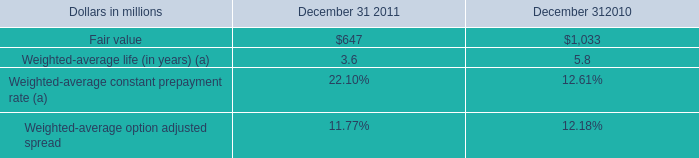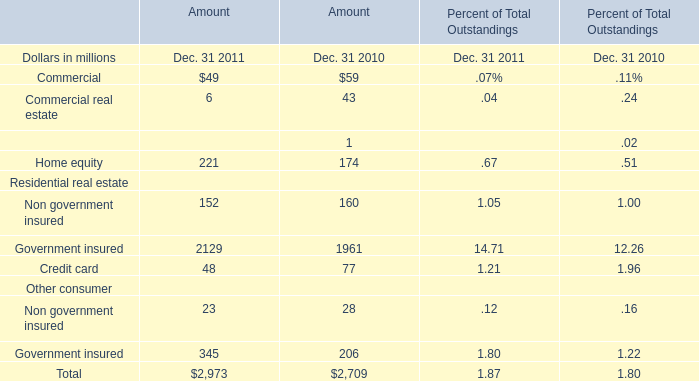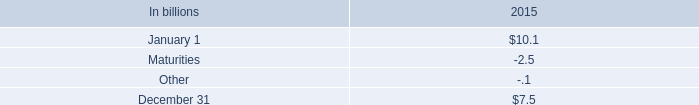What's the greatest value of Commercial in 2011? (in million) 
Answer: 49. 